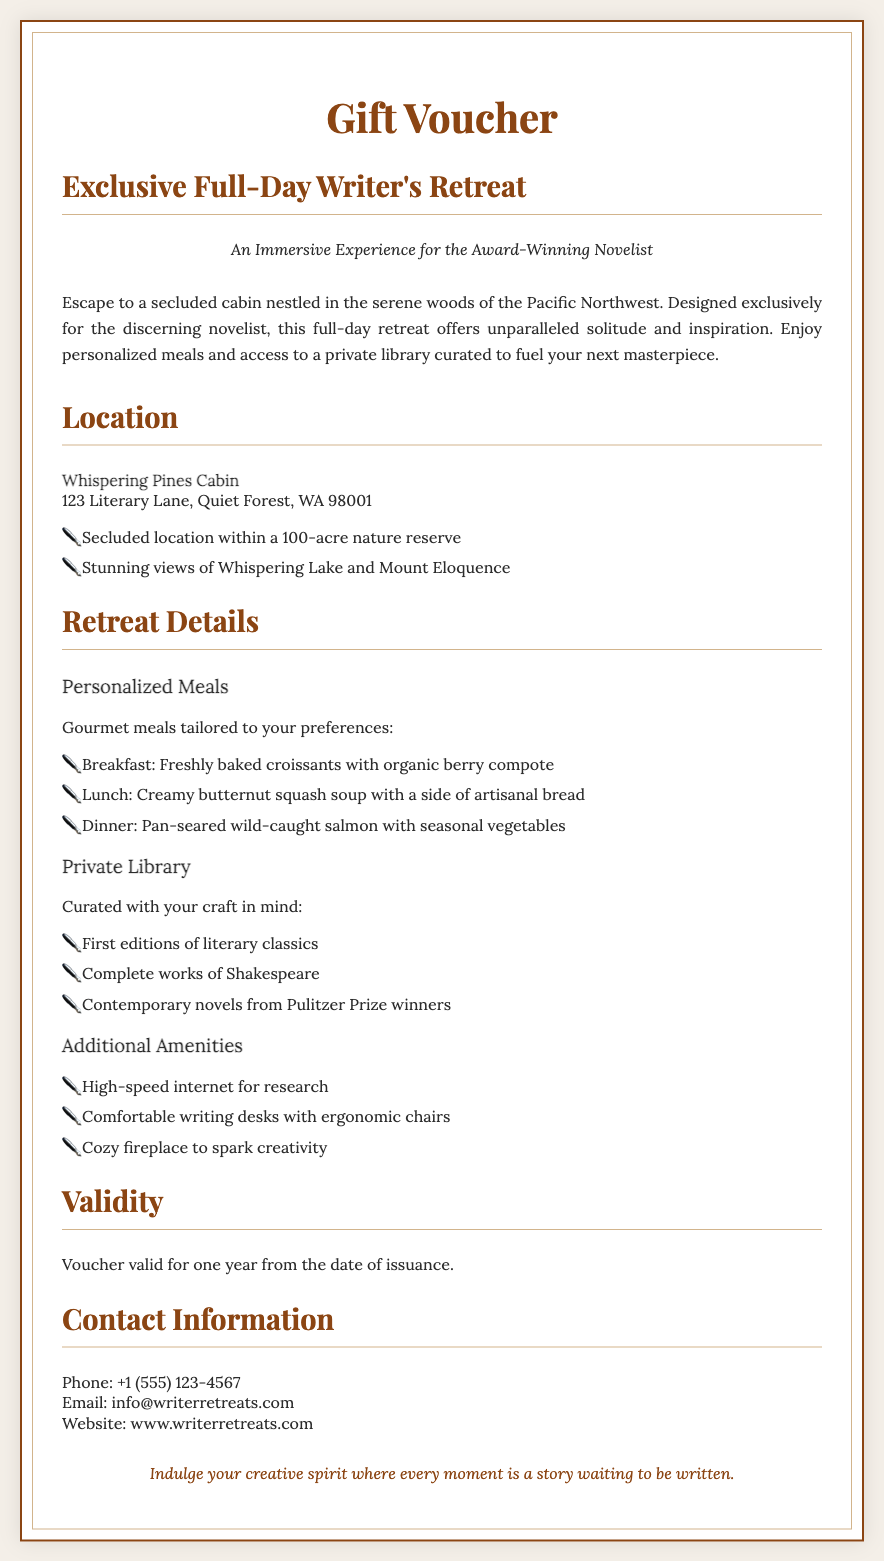What is the title of the voucher? The title of the voucher is prominently displayed at the top, which is "Exclusive Full-Day Writer's Retreat."
Answer: Exclusive Full-Day Writer's Retreat What type of meals are provided? The document specifies that gourmet meals are tailored to preferences, indicating the quality and personalization of the meals.
Answer: Personalized meals Where is the retreat located? The location details are specifically given under the location section, which states "Whispering Pines Cabin."
Answer: Whispering Pines Cabin What is the validity period of the voucher? The document clearly mentions the validity of the voucher in the validity section, stating it is valid for one year.
Answer: One year What amenities are mentioned in the retreat details? The details section lists various amenities that enhance the retreat experience, such as high-speed internet and comfortable writing desks.
Answer: High-speed internet What kind of library access is offered? The document outlines that there is access to a private library curated with literary works aimed at inspiring writers.
Answer: Private library What is the contact email provided? The contact information section provides specific email details for inquiries, which is listed clearly in the document.
Answer: info@writerretreats.com What type of atmosphere does the retreat promote? The description emphasizes solitude and inspiration, indicating a serene setting for creativity.
Answer: Serenity and inspiration What specific culinary item is served for lunch? The document lists a specific lunch item under the personalized meals, detailing what guests can expect during their stay.
Answer: Creamy butternut squash soup 